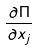Convert formula to latex. <formula><loc_0><loc_0><loc_500><loc_500>\frac { \partial \Pi } { \partial x _ { j } }</formula> 